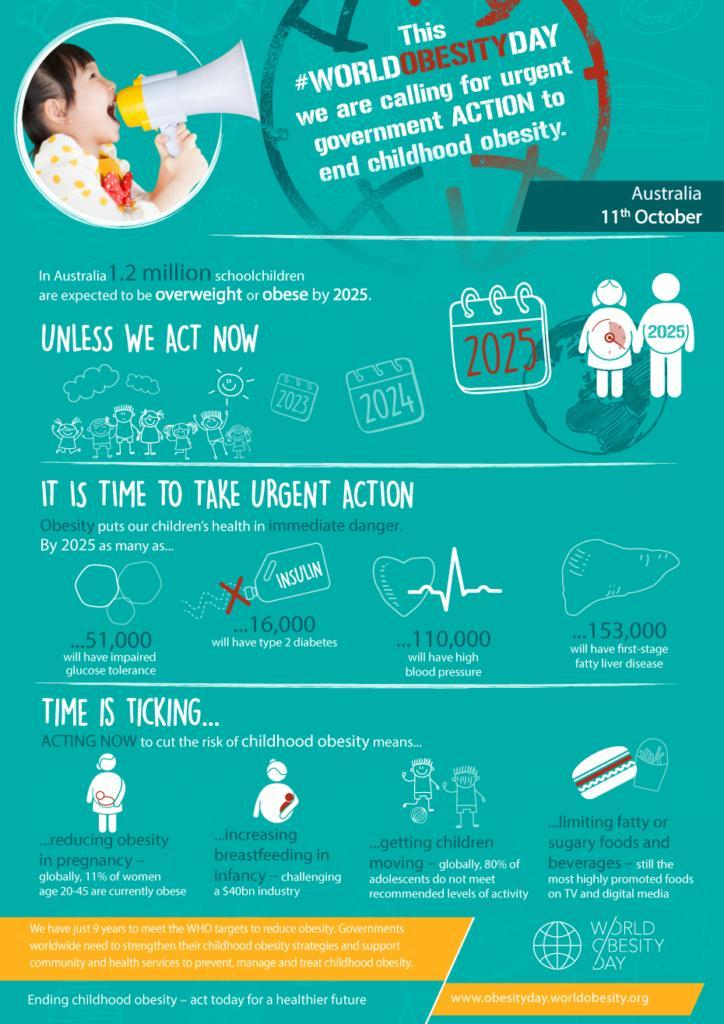How many children will be diagnosed with high glucose levels by 2050?
Answer the question with a short phrase. 51,000 How many children will be diagnosed with increased BP by 2050? 110,000 What kind of snacks can lead to obesity? fatty or sugary foods and beverages How many children will be diagnosed with Type 2 diabetes by 2050? 16,000 What is the second method mentioned in the infographic to prevent obesity? increasing breastfeeding in infancy 